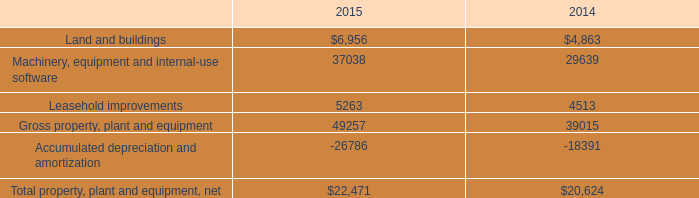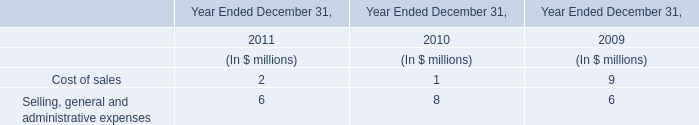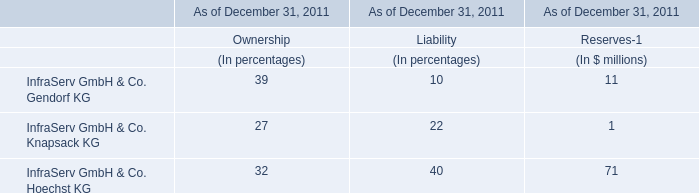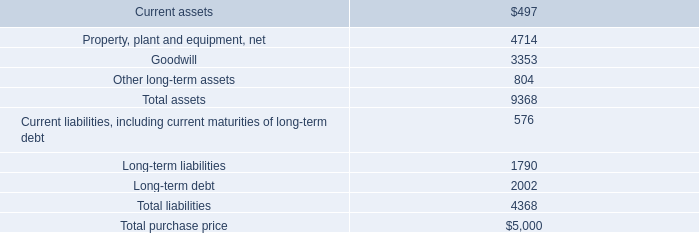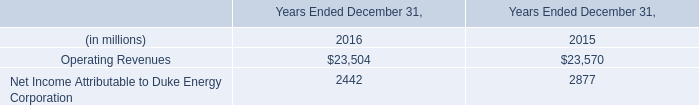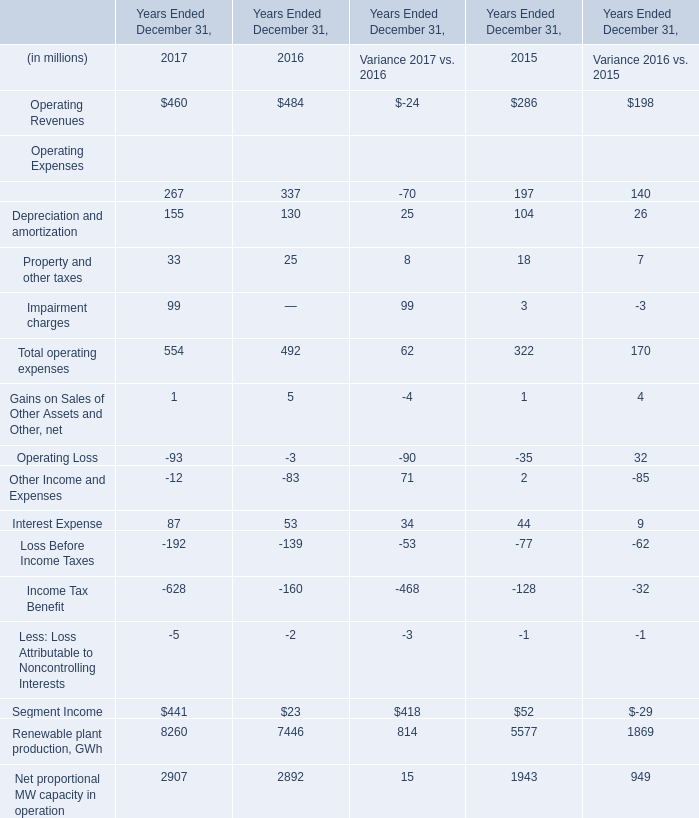Does the value of Operating Revenues in 2017 greater than that in Total operating expenses? 
Answer: No. 